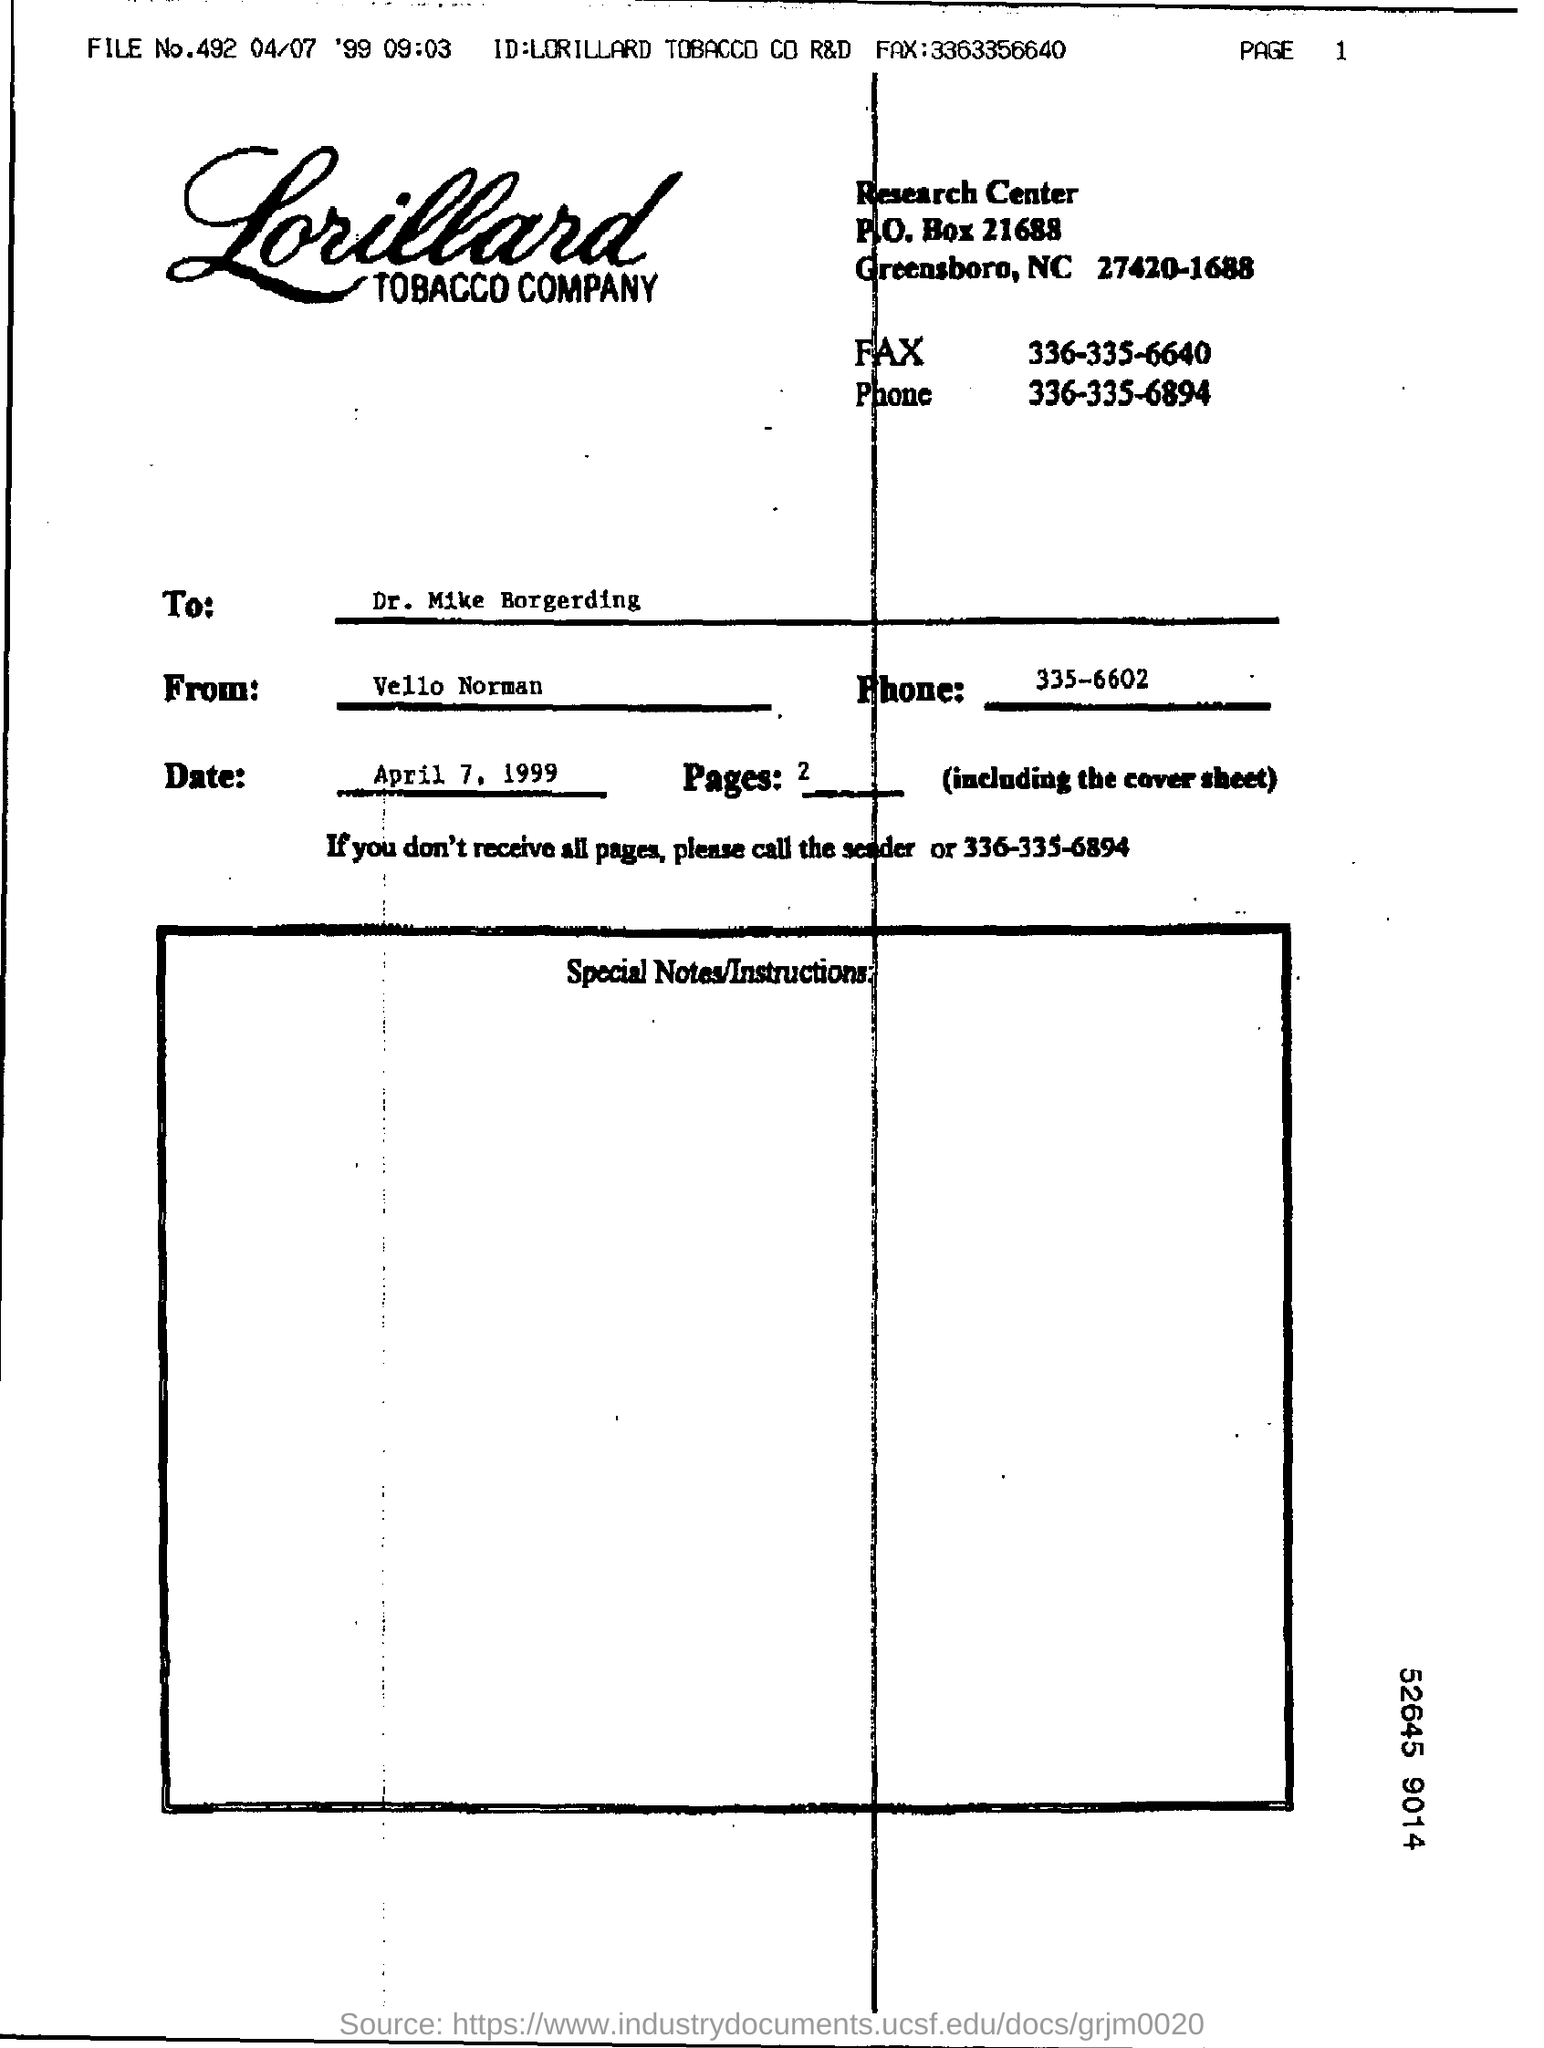Draw attention to some important aspects in this diagram. This document is addressed to Dr. Mike Borgerding. This document was written by Vello Norman. The tobacco company's name is Lorillard. The date mentioned is April 7, 1999. 